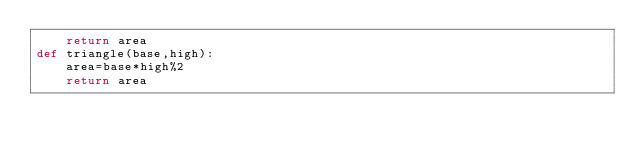<code> <loc_0><loc_0><loc_500><loc_500><_Python_>    return area
def triangle(base,high):
    area=base*high%2
    return area
</code> 